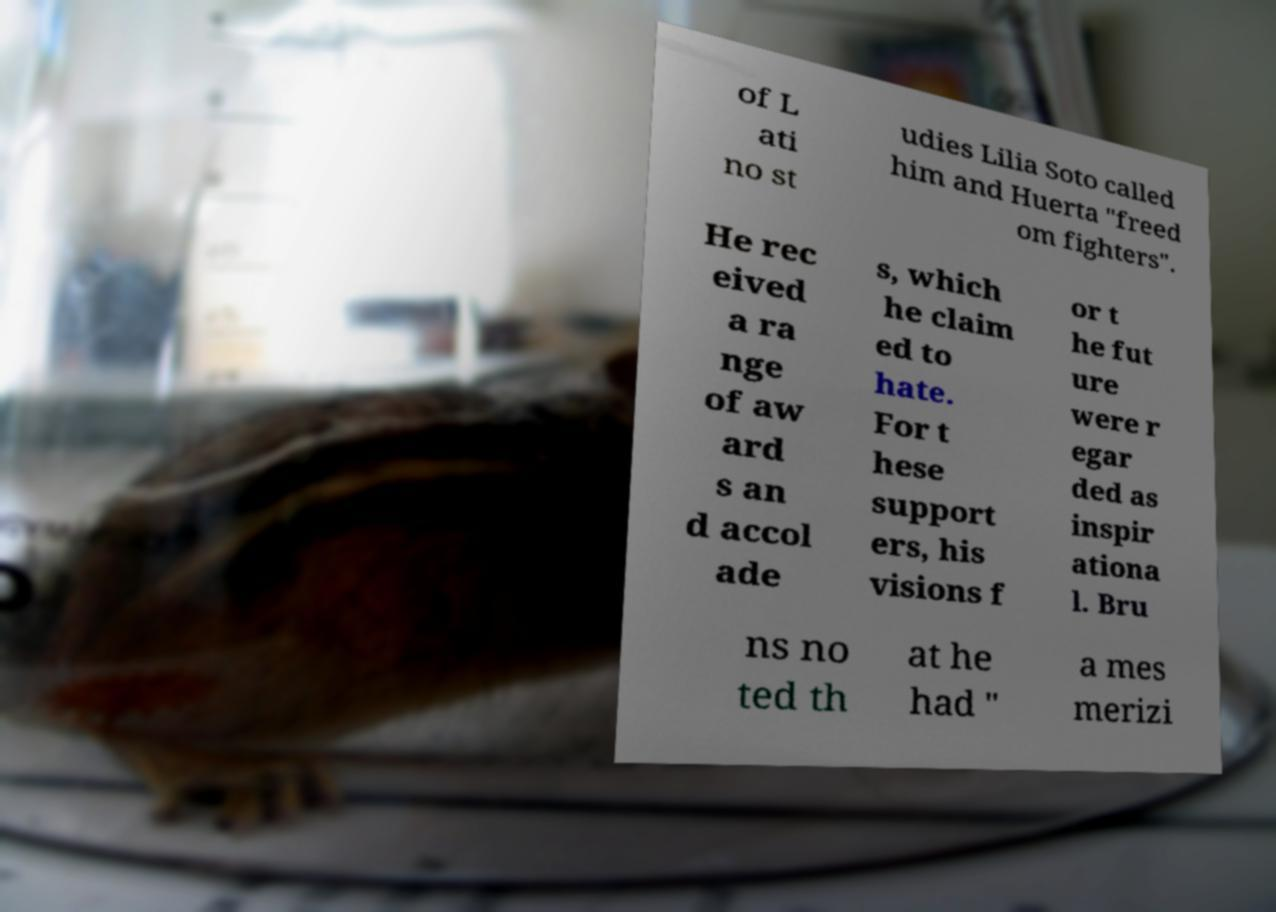Please read and relay the text visible in this image. What does it say? of L ati no st udies Lilia Soto called him and Huerta "freed om fighters". He rec eived a ra nge of aw ard s an d accol ade s, which he claim ed to hate. For t hese support ers, his visions f or t he fut ure were r egar ded as inspir ationa l. Bru ns no ted th at he had " a mes merizi 